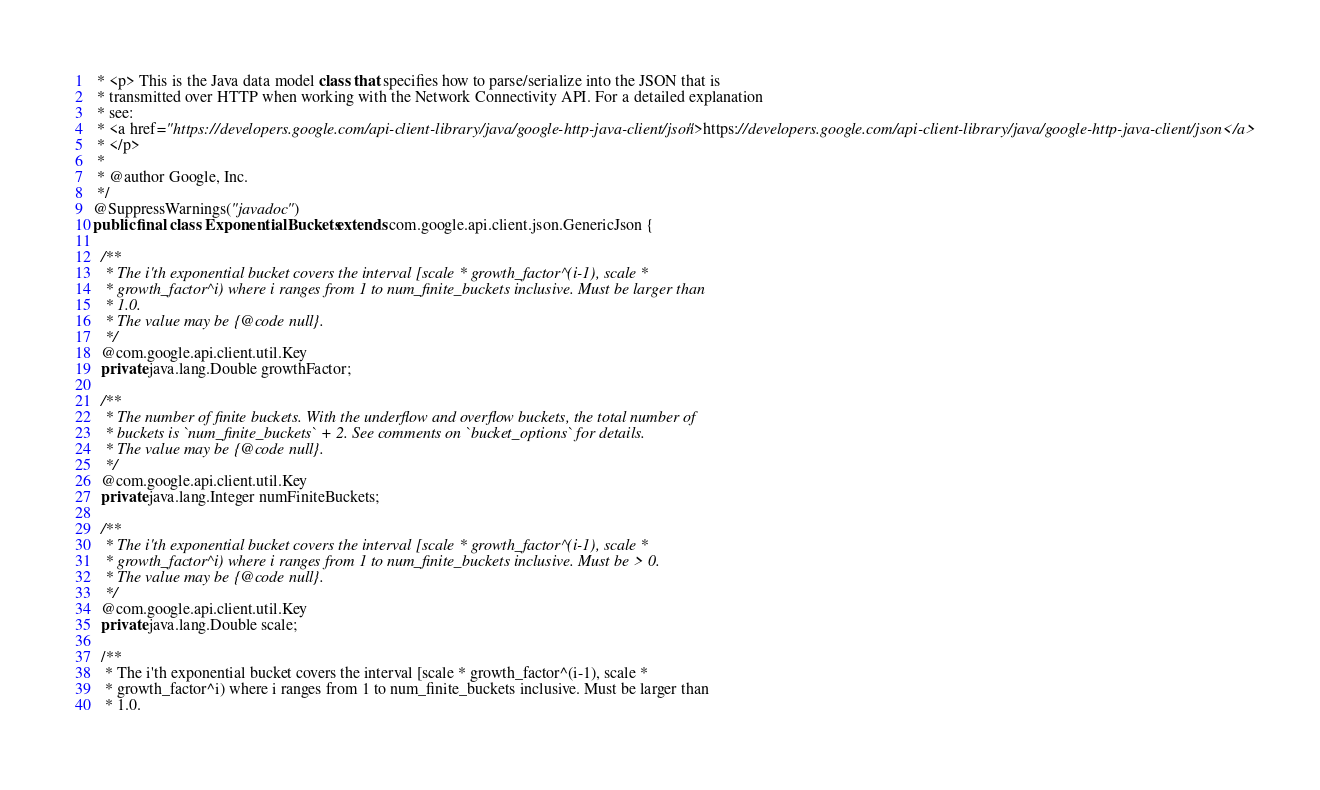<code> <loc_0><loc_0><loc_500><loc_500><_Java_> * <p> This is the Java data model class that specifies how to parse/serialize into the JSON that is
 * transmitted over HTTP when working with the Network Connectivity API. For a detailed explanation
 * see:
 * <a href="https://developers.google.com/api-client-library/java/google-http-java-client/json">https://developers.google.com/api-client-library/java/google-http-java-client/json</a>
 * </p>
 *
 * @author Google, Inc.
 */
@SuppressWarnings("javadoc")
public final class ExponentialBuckets extends com.google.api.client.json.GenericJson {

  /**
   * The i'th exponential bucket covers the interval [scale * growth_factor^(i-1), scale *
   * growth_factor^i) where i ranges from 1 to num_finite_buckets inclusive. Must be larger than
   * 1.0.
   * The value may be {@code null}.
   */
  @com.google.api.client.util.Key
  private java.lang.Double growthFactor;

  /**
   * The number of finite buckets. With the underflow and overflow buckets, the total number of
   * buckets is `num_finite_buckets` + 2. See comments on `bucket_options` for details.
   * The value may be {@code null}.
   */
  @com.google.api.client.util.Key
  private java.lang.Integer numFiniteBuckets;

  /**
   * The i'th exponential bucket covers the interval [scale * growth_factor^(i-1), scale *
   * growth_factor^i) where i ranges from 1 to num_finite_buckets inclusive. Must be > 0.
   * The value may be {@code null}.
   */
  @com.google.api.client.util.Key
  private java.lang.Double scale;

  /**
   * The i'th exponential bucket covers the interval [scale * growth_factor^(i-1), scale *
   * growth_factor^i) where i ranges from 1 to num_finite_buckets inclusive. Must be larger than
   * 1.0.</code> 